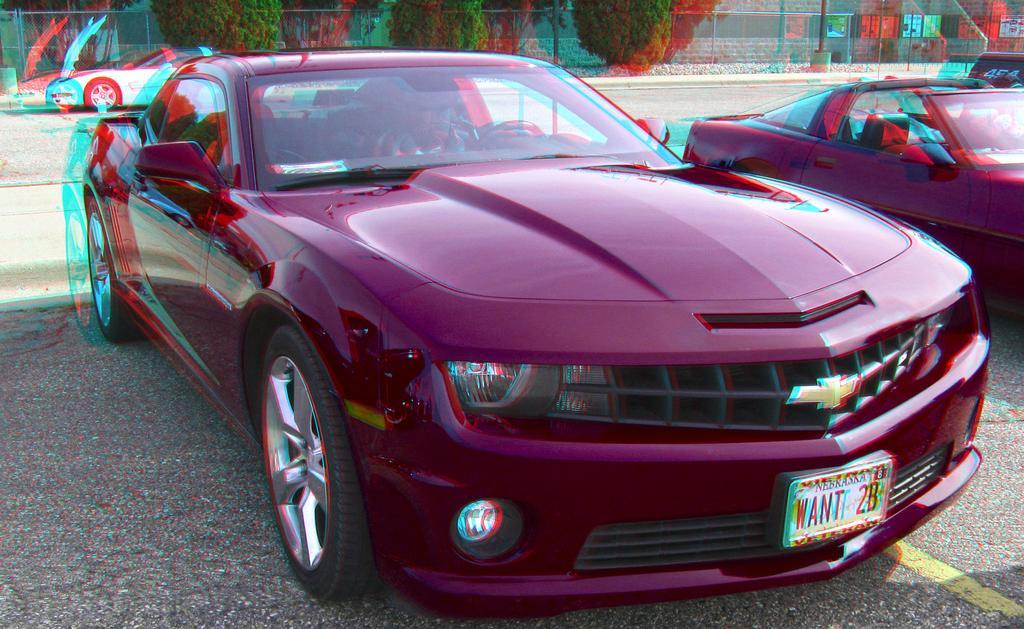Describe this image in one or two sentences. This is an edited image , where there are cars parked on the path , and in the background there are plants, trees, wire fence, building. 